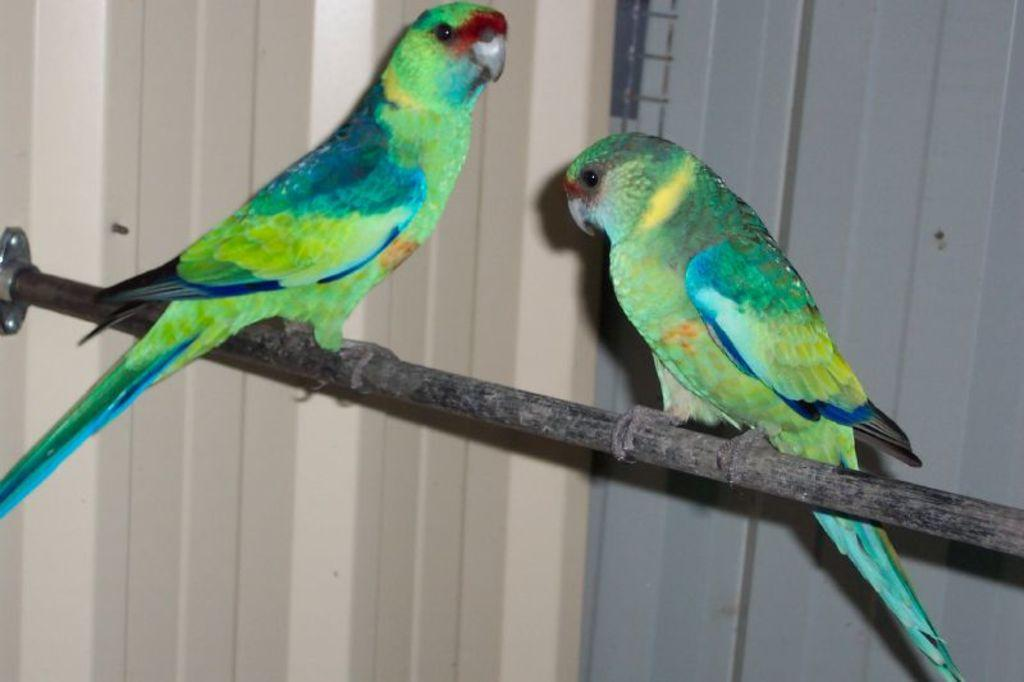What object is present in the image that has two parrots on it? There is a stick in the image with two parrots on it. Can you describe the background of the image? There is a wall in the background of the image. How many fingers can be seen on the stick in the image? There are no fingers visible on the stick in the image; it only has two parrots on it. What type of tree is the stick made from in the image? There is no information about the type of tree the stick is made from in the image. 